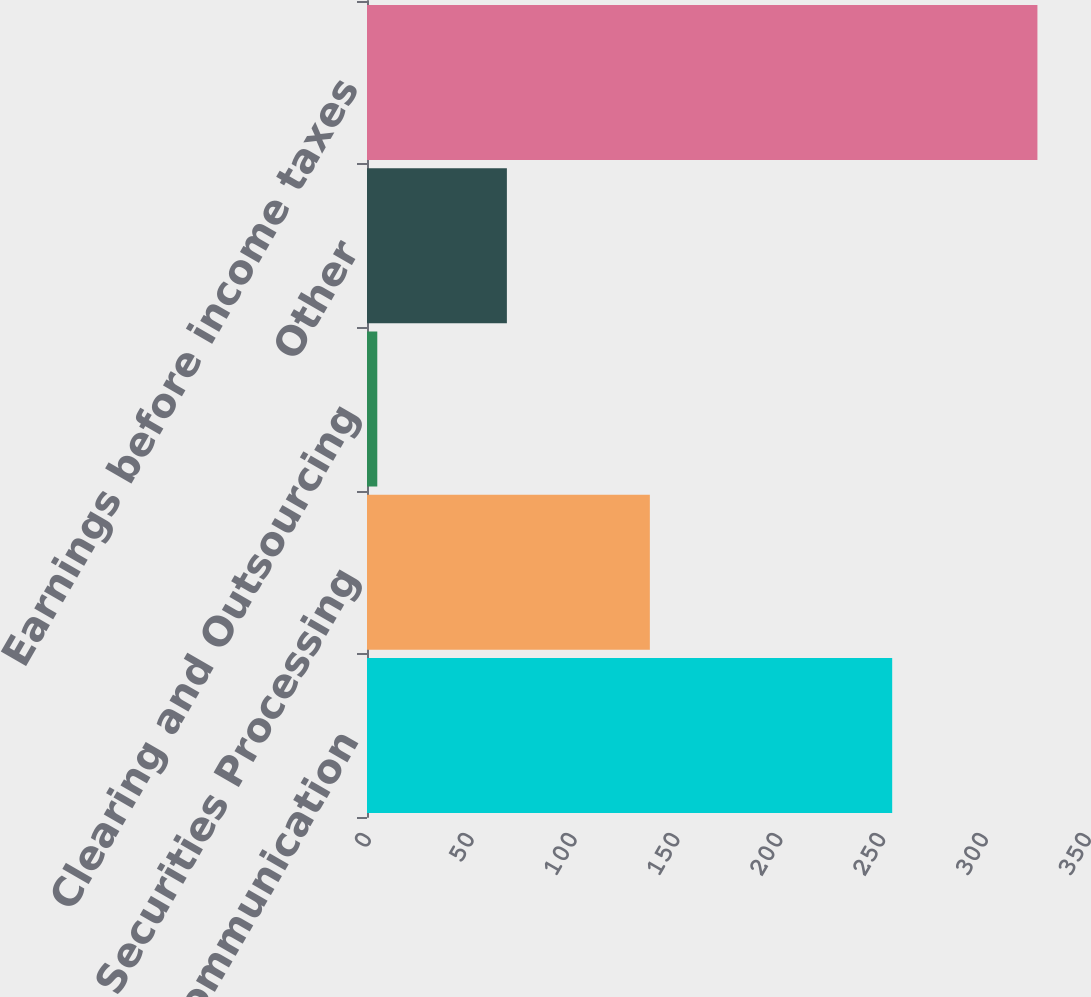<chart> <loc_0><loc_0><loc_500><loc_500><bar_chart><fcel>Investor Communication<fcel>Securities Processing<fcel>Clearing and Outsourcing<fcel>Other<fcel>Earnings before income taxes<nl><fcel>255.3<fcel>137.5<fcel>5<fcel>68<fcel>325.9<nl></chart> 